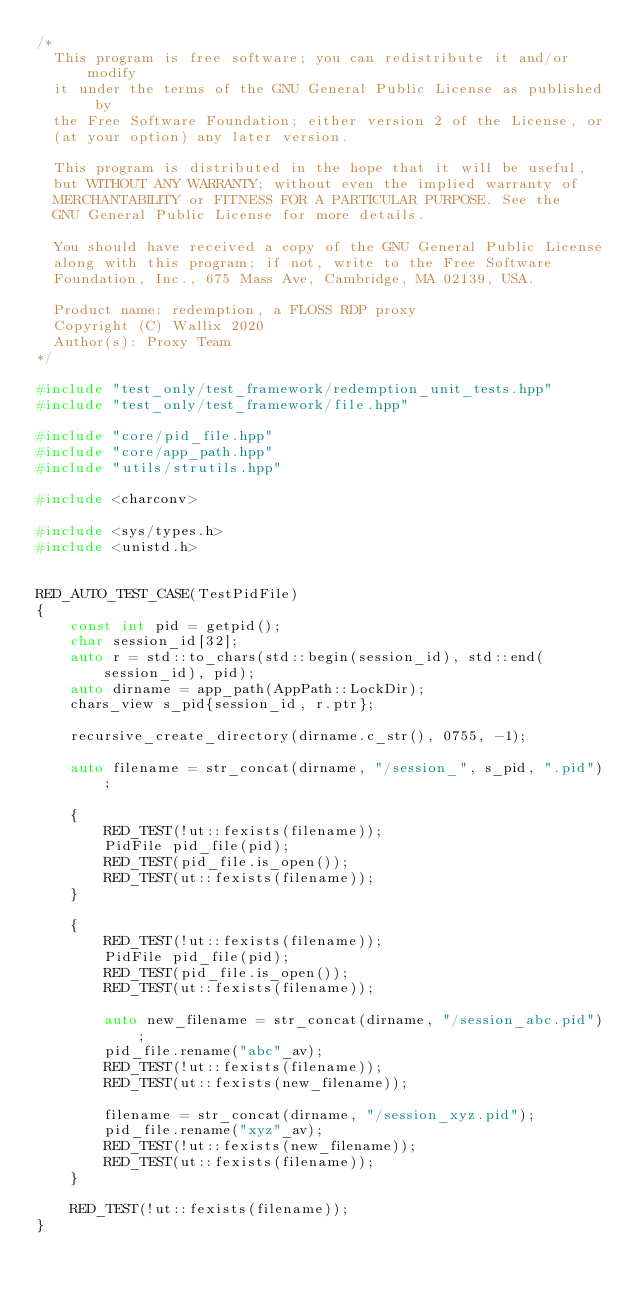<code> <loc_0><loc_0><loc_500><loc_500><_C++_>/*
  This program is free software; you can redistribute it and/or modify
  it under the terms of the GNU General Public License as published by
  the Free Software Foundation; either version 2 of the License, or
  (at your option) any later version.

  This program is distributed in the hope that it will be useful,
  but WITHOUT ANY WARRANTY; without even the implied warranty of
  MERCHANTABILITY or FITNESS FOR A PARTICULAR PURPOSE. See the
  GNU General Public License for more details.

  You should have received a copy of the GNU General Public License
  along with this program; if not, write to the Free Software
  Foundation, Inc., 675 Mass Ave, Cambridge, MA 02139, USA.

  Product name: redemption, a FLOSS RDP proxy
  Copyright (C) Wallix 2020
  Author(s): Proxy Team
*/

#include "test_only/test_framework/redemption_unit_tests.hpp"
#include "test_only/test_framework/file.hpp"

#include "core/pid_file.hpp"
#include "core/app_path.hpp"
#include "utils/strutils.hpp"

#include <charconv>

#include <sys/types.h>
#include <unistd.h>


RED_AUTO_TEST_CASE(TestPidFile)
{
    const int pid = getpid();
    char session_id[32];
    auto r = std::to_chars(std::begin(session_id), std::end(session_id), pid);
    auto dirname = app_path(AppPath::LockDir);
    chars_view s_pid{session_id, r.ptr};

    recursive_create_directory(dirname.c_str(), 0755, -1);

    auto filename = str_concat(dirname, "/session_", s_pid, ".pid");

    {
        RED_TEST(!ut::fexists(filename));
        PidFile pid_file(pid);
        RED_TEST(pid_file.is_open());
        RED_TEST(ut::fexists(filename));
    }

    {
        RED_TEST(!ut::fexists(filename));
        PidFile pid_file(pid);
        RED_TEST(pid_file.is_open());
        RED_TEST(ut::fexists(filename));

        auto new_filename = str_concat(dirname, "/session_abc.pid");
        pid_file.rename("abc"_av);
        RED_TEST(!ut::fexists(filename));
        RED_TEST(ut::fexists(new_filename));

        filename = str_concat(dirname, "/session_xyz.pid");
        pid_file.rename("xyz"_av);
        RED_TEST(!ut::fexists(new_filename));
        RED_TEST(ut::fexists(filename));
    }

    RED_TEST(!ut::fexists(filename));
}
</code> 